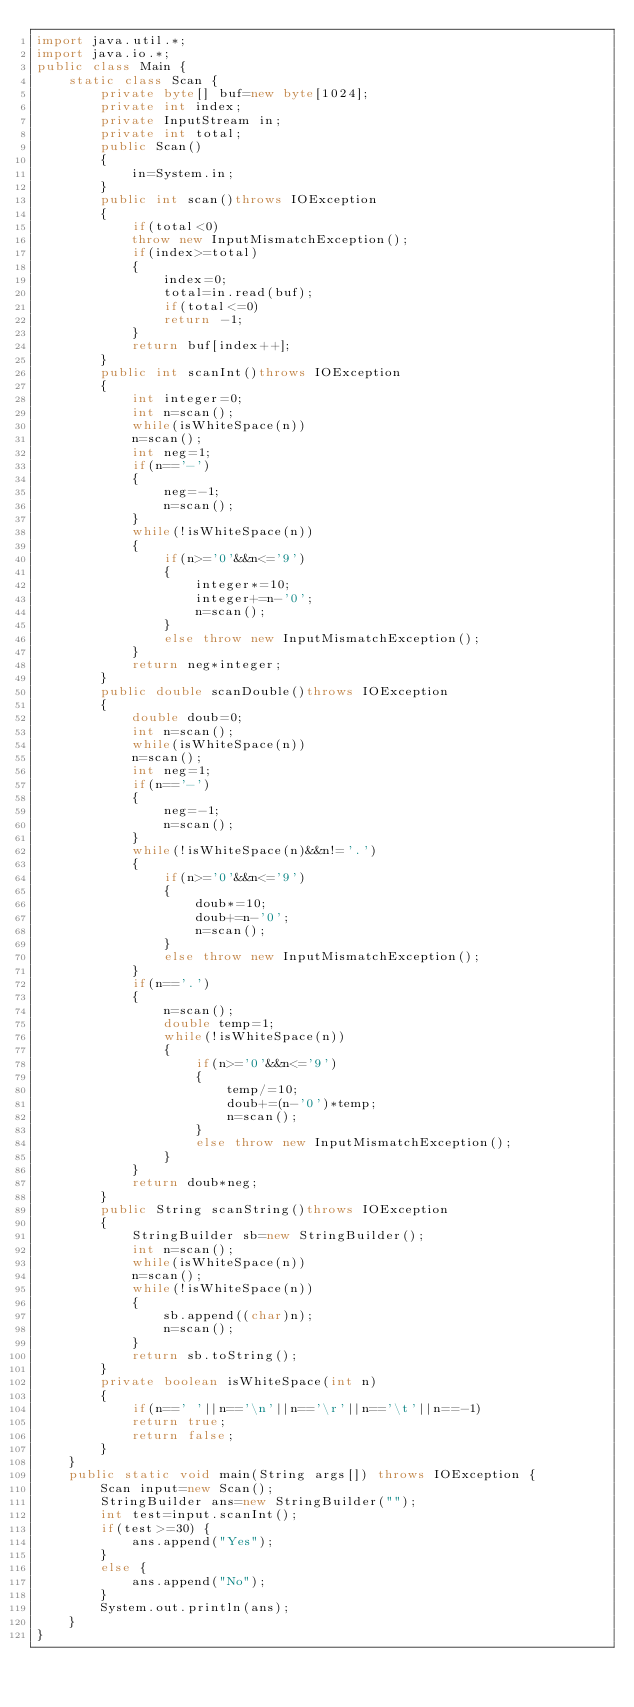<code> <loc_0><loc_0><loc_500><loc_500><_Java_>import java.util.*;
import java.io.*;
public class Main {
    static class Scan {
        private byte[] buf=new byte[1024];
        private int index;
        private InputStream in;
        private int total;
        public Scan()
        {
            in=System.in;
        }
        public int scan()throws IOException
        {
            if(total<0)
            throw new InputMismatchException();
            if(index>=total)
            {
                index=0;
                total=in.read(buf);
                if(total<=0)
                return -1;
            }
            return buf[index++];
        }
        public int scanInt()throws IOException
        {
            int integer=0;
            int n=scan();
            while(isWhiteSpace(n))
            n=scan();
            int neg=1;
            if(n=='-')
            {
                neg=-1;
                n=scan();
            }
            while(!isWhiteSpace(n))
            {
                if(n>='0'&&n<='9')
                {
                    integer*=10;
                    integer+=n-'0';
                    n=scan();
                }
                else throw new InputMismatchException();
            }
            return neg*integer;
        }
        public double scanDouble()throws IOException
        {
            double doub=0;
            int n=scan();
            while(isWhiteSpace(n))
            n=scan();
            int neg=1;
            if(n=='-')
            {
                neg=-1;
                n=scan();
            }
            while(!isWhiteSpace(n)&&n!='.')
            {
                if(n>='0'&&n<='9')
                {
                    doub*=10;
                    doub+=n-'0';
                    n=scan();
                }
                else throw new InputMismatchException();
            }
            if(n=='.')
            {
                n=scan();
                double temp=1;
                while(!isWhiteSpace(n))
                {
                    if(n>='0'&&n<='9')
                    {
                        temp/=10;
                        doub+=(n-'0')*temp;
                        n=scan();
                    }
                    else throw new InputMismatchException();
                }
            }
            return doub*neg;
        }
        public String scanString()throws IOException
        {
            StringBuilder sb=new StringBuilder();
            int n=scan();
            while(isWhiteSpace(n))
            n=scan();
            while(!isWhiteSpace(n))
            {
                sb.append((char)n);
                n=scan();
            }
            return sb.toString();
        }
        private boolean isWhiteSpace(int n)
        {
            if(n==' '||n=='\n'||n=='\r'||n=='\t'||n==-1)
            return true;
            return false;
        }
    }
    public static void main(String args[]) throws IOException {
        Scan input=new Scan();
        StringBuilder ans=new StringBuilder("");
        int test=input.scanInt();
        if(test>=30) {
            ans.append("Yes");
        }
        else {
            ans.append("No");
        }
        System.out.println(ans);
    }
}
</code> 